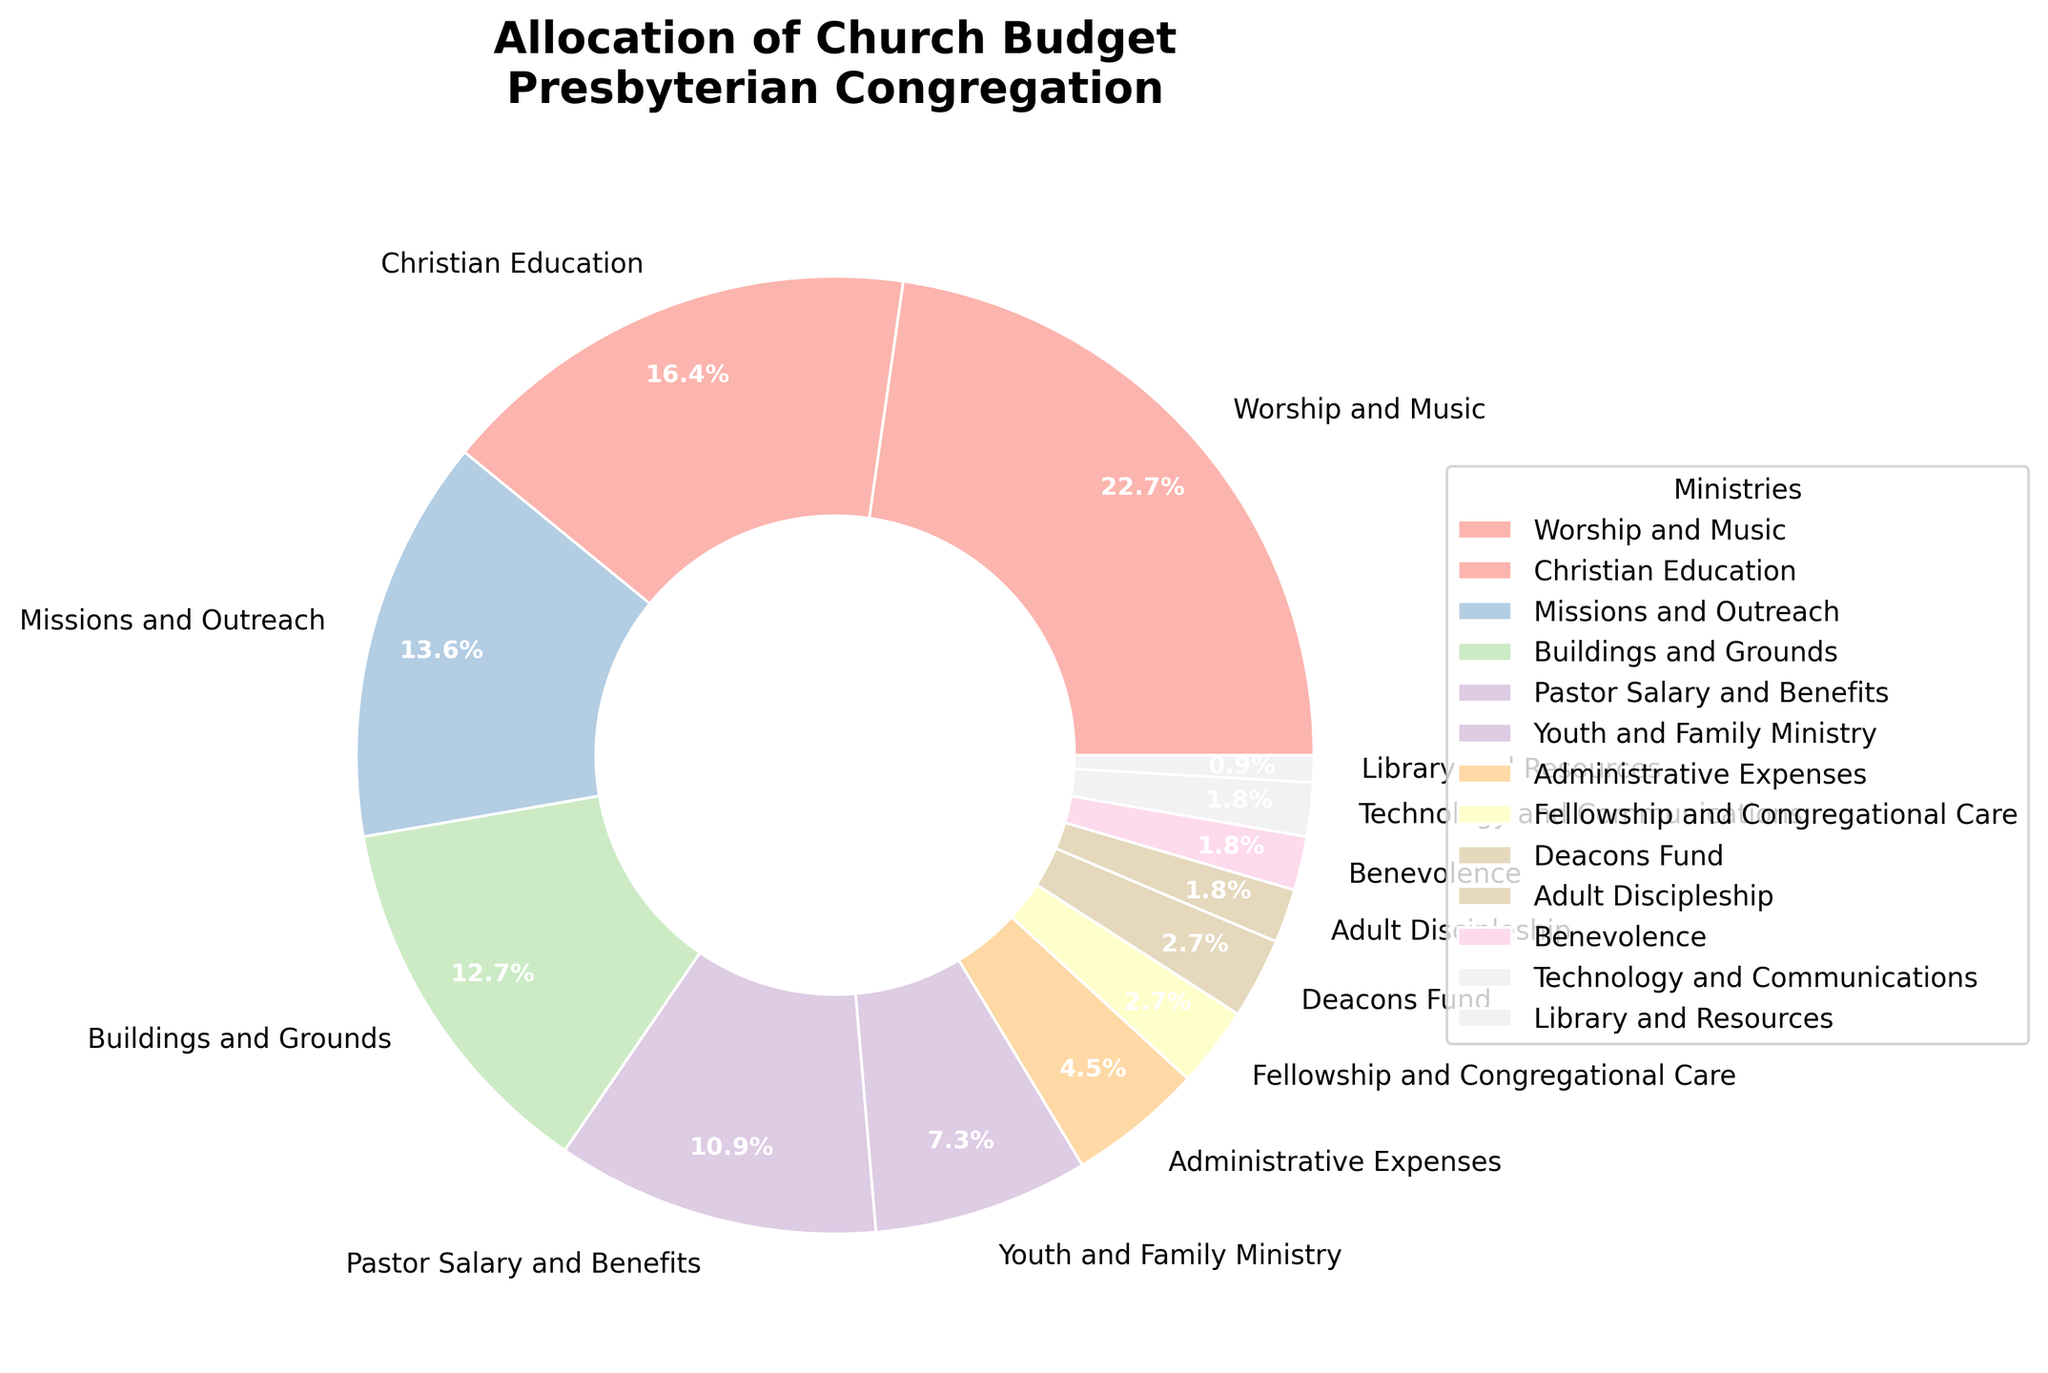What percentage of the church budget is allocated to Youth and Family Ministry? Locate 'Youth and Family Ministry' on the pie chart and refer to its associated percentage label.
Answer: 8% Which ministry receives a greater budget allocation, Missions and Outreach or Buildings and Grounds? Compare the percentages of 'Missions and Outreach' and 'Buildings and Grounds' on the pie chart.
Answer: Missions and Outreach What is the combined percentage of the budget allocated to Worship and Music and Pastor Salary and Benefits? Identify the percentages for 'Worship and Music' and 'Pastor Salary and Benefits' on the pie chart. Add these values together. 25% + 12% = 37%
Answer: 37% Are the combined allocations for Deacons Fund and Fellowship and Congregational Care greater than the allocation for Christian Education? Sum the percentages of 'Deacons Fund' and 'Fellowship and Congregational Care'. Compare this sum to the percentage for 'Christian Education' (3% + 3% = 6% vs 18%).
Answer: No Which ministry has the smallest allocation, and what is its percentage? Find the ministry with the smallest percentage on the pie chart.
Answer: Library and Resources, 1% How much more percentage is allocated to Worship and Music than to Technology and Communications? Subtract the percentage of 'Technology and Communications' from that of 'Worship and Music' (25% - 2%).
Answer: 23% Is the percentage allocated to Administrative Expenses greater than Pastor Salary and Benefits? Compare the percentages of 'Administrative Expenses' and 'Pastor Salary and Benefits' on the pie chart.
Answer: No What is the total percentage allocated to all ministries receiving less than 5% each? Identify and sum the percentages of ministries receiving less than 5% (Deacons Fund, Fellowship and Congregational Care, Technology and Communications, Benevolence, Adult Discipleship, Library and Resources: 3% + 3% + 2% + 2% + 2% + 1% = 13%).
Answer: 13% Which ministry receiving more than 10% is closest in allocation to Youth and Family Ministry? Identify ministries receiving more than 10% and compare their percentages to 'Youth and Family Ministry' (18% Christian Education, 15% Missions and Outreach, 14% Buildings and Grounds, 12% Pastor Salary and Benefits; closest is 'Pastor Salary and Benefits').
Answer: Pastor Salary and Benefits Is the total percentage for all education-related ministries greater than or less than 20%? Sum the percentages for 'Christian Education' (18%) and 'Adult Discipleship' (2%). Compare to 20% (18% + 2% = 20%).
Answer: Equal to 20% 